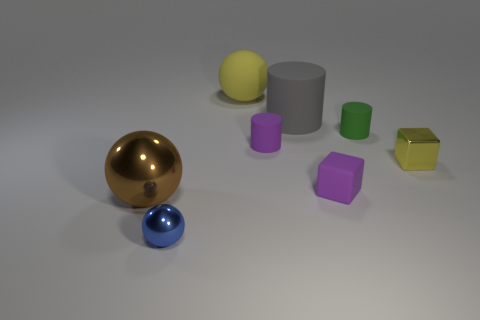What material is the object in front of the shiny ball to the left of the blue sphere made of? The object in question appears to be a cylinder made of a matte material, likely plastic or rubber, given its dull surface which contrasts with the reflective metal of the ball close to it. 